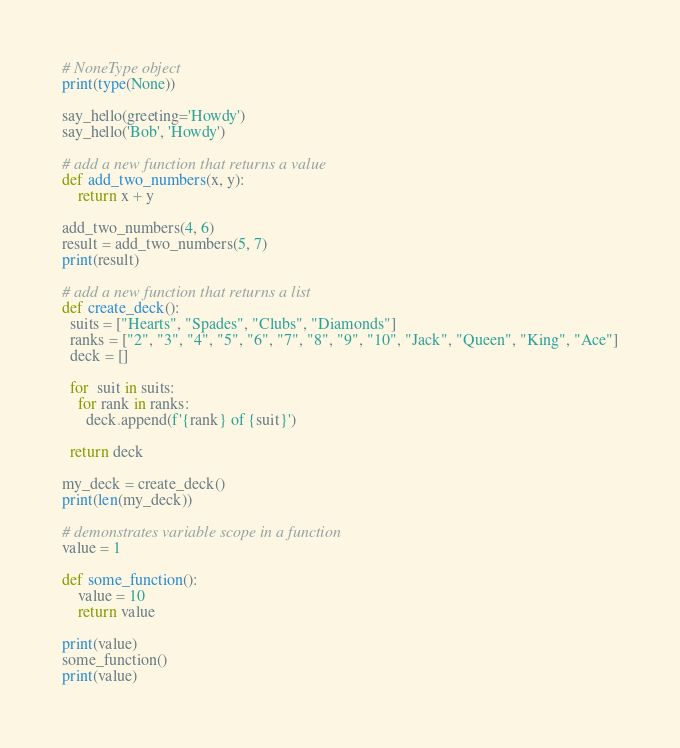Convert code to text. <code><loc_0><loc_0><loc_500><loc_500><_Python_>
# NoneType object
print(type(None))

say_hello(greeting='Howdy')
say_hello('Bob', 'Howdy')

# add a new function that returns a value
def add_two_numbers(x, y):
    return x + y

add_two_numbers(4, 6)
result = add_two_numbers(5, 7)
print(result)

# add a new function that returns a list
def create_deck():
  suits = ["Hearts", "Spades", "Clubs", "Diamonds"]
  ranks = ["2", "3", "4", "5", "6", "7", "8", "9", "10", "Jack", "Queen", "King", "Ace"]
  deck = []

  for  suit in suits:
    for rank in ranks:
      deck.append(f'{rank} of {suit}')

  return deck

my_deck = create_deck()
print(len(my_deck))

# demonstrates variable scope in a function
value = 1

def some_function():
    value = 10
    return value

print(value)
some_function()
print(value)</code> 